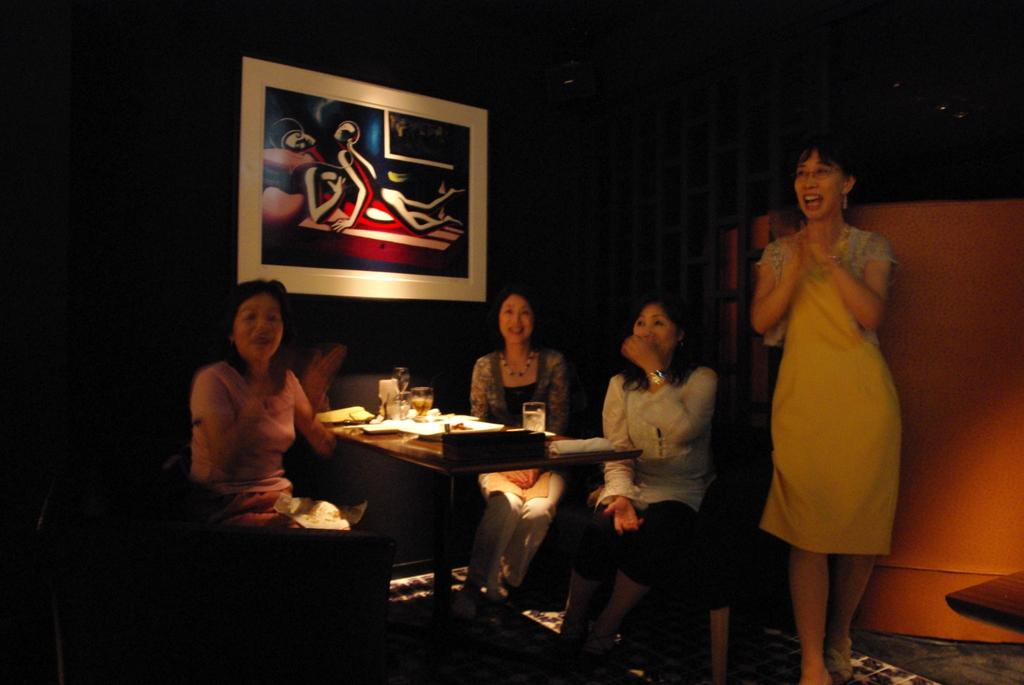What are the people in the image doing? People are sitting around the table in the image. Is there anyone standing in the image? Yes, there is a person standing at the right side. What objects can be seen on the table? There are glass items and plates on the table. What decorative item is visible behind the people? There is a photo frame visible behind the people. What type of vest can be seen on the person at the left side of the image? There is no vest visible on any person in the image. Can you see any ants crawling on the table in the image? There are no ants present in the image. 